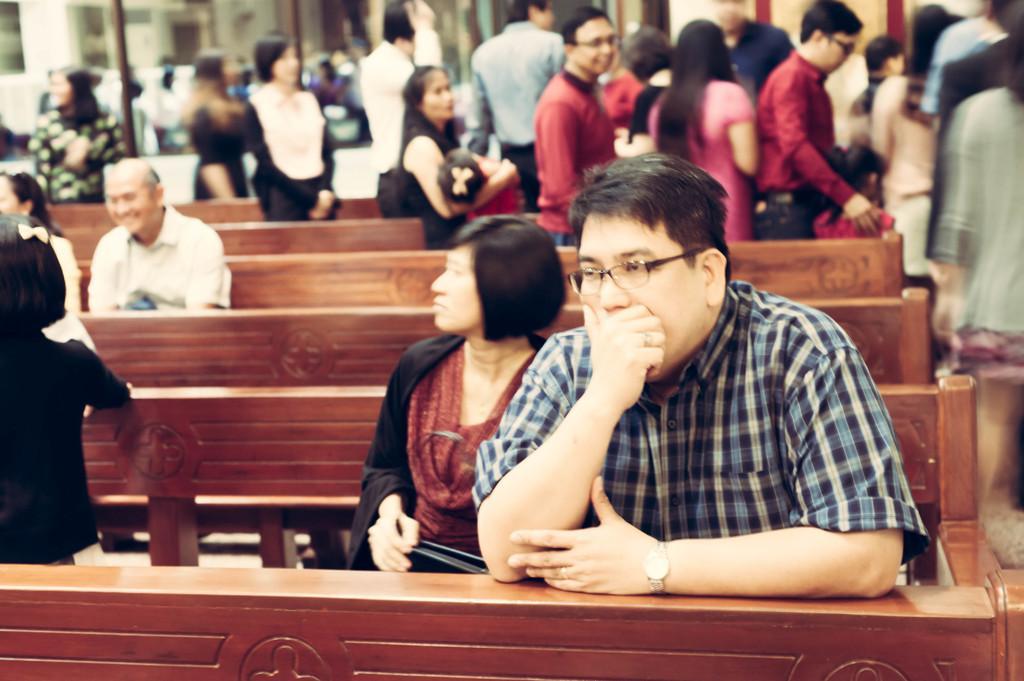Can you describe this image briefly? In this picture we can see people standing and few are sitting on the benches. 